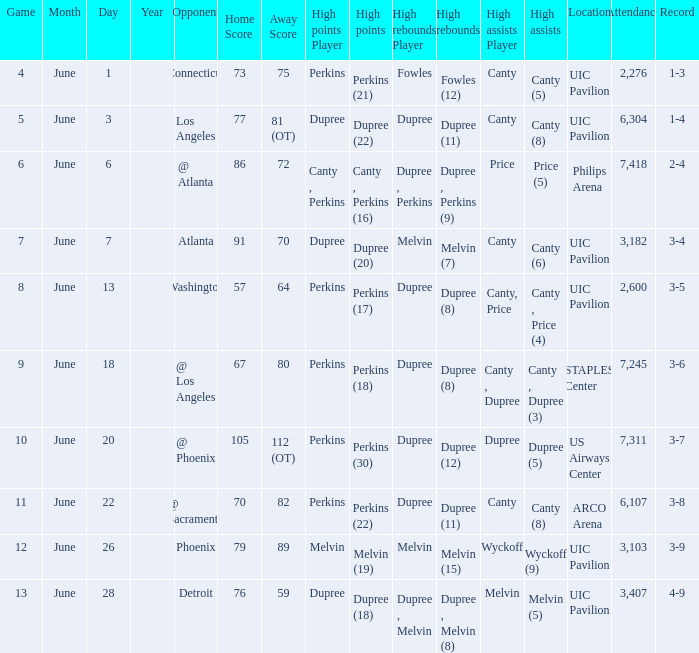What is the date of game 9? June 18. 